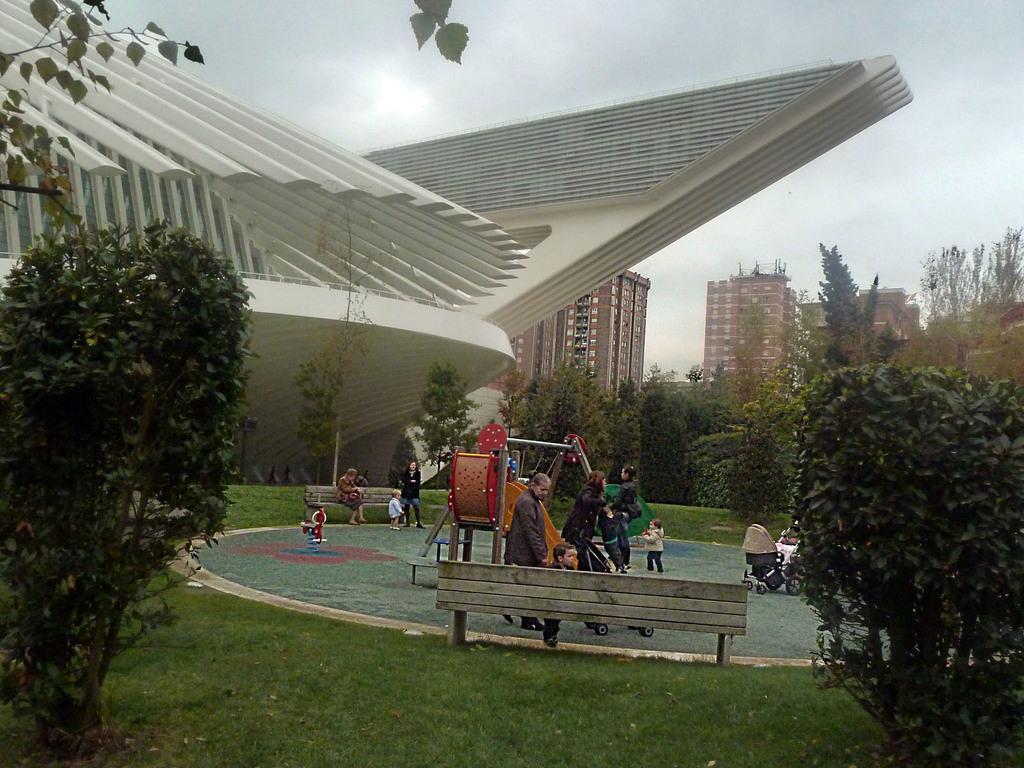In one or two sentences, can you explain what this image depicts? In this image I can see few people. These people are wearing the different color dresses. These people are to the side of the slides. I can see few people are sitting on the benches. Around these people there are many trees and buildings. In the back I can see the sky. 